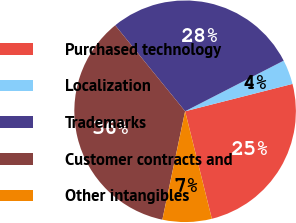Convert chart. <chart><loc_0><loc_0><loc_500><loc_500><pie_chart><fcel>Purchased technology<fcel>Localization<fcel>Trademarks<fcel>Customer contracts and<fcel>Other intangibles<nl><fcel>25.09%<fcel>3.58%<fcel>28.32%<fcel>35.84%<fcel>7.17%<nl></chart> 